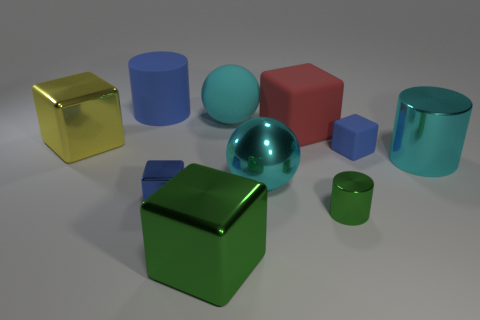What number of big things have the same shape as the tiny green object?
Offer a terse response. 2. What shape is the tiny blue thing that is made of the same material as the yellow block?
Offer a terse response. Cube. The metallic block to the right of the tiny cube that is left of the tiny green metal object is what color?
Provide a short and direct response. Green. Is the small matte cube the same color as the matte cylinder?
Provide a succinct answer. Yes. There is a big cyan ball that is left of the cyan ball that is in front of the cyan matte object; what is it made of?
Offer a terse response. Rubber. There is a yellow object that is the same shape as the large green object; what material is it?
Your response must be concise. Metal. Are there any blue matte things left of the thing in front of the small thing that is in front of the small blue metallic object?
Give a very brief answer. Yes. How many other objects are there of the same color as the large matte cylinder?
Ensure brevity in your answer.  2. How many big blocks are on the right side of the metal ball and on the left side of the big blue cylinder?
Provide a succinct answer. 0. What is the shape of the big yellow metal thing?
Your answer should be compact. Cube. 